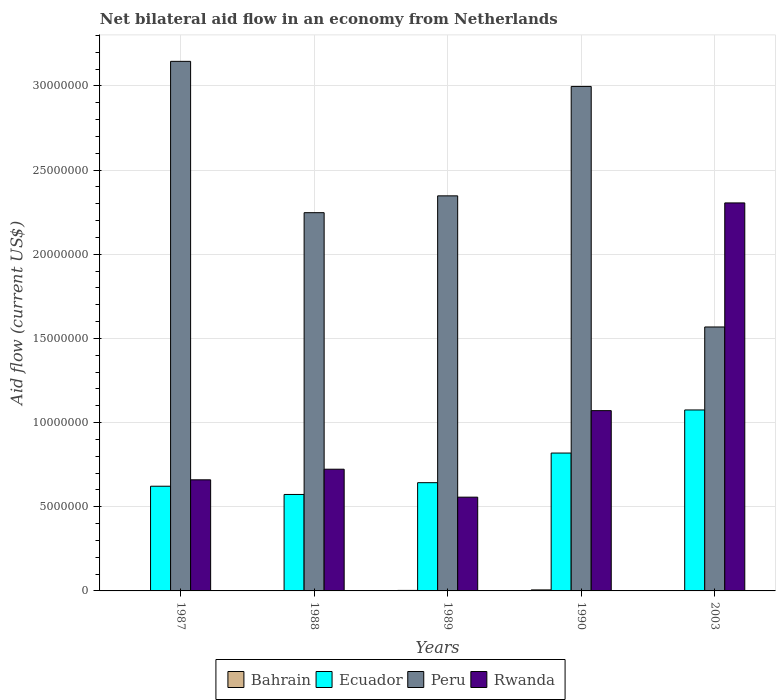How many different coloured bars are there?
Provide a succinct answer. 4. Are the number of bars on each tick of the X-axis equal?
Offer a very short reply. Yes. How many bars are there on the 4th tick from the left?
Your answer should be very brief. 4. What is the label of the 5th group of bars from the left?
Provide a succinct answer. 2003. In how many cases, is the number of bars for a given year not equal to the number of legend labels?
Your answer should be compact. 0. What is the net bilateral aid flow in Rwanda in 1988?
Provide a succinct answer. 7.23e+06. Across all years, what is the maximum net bilateral aid flow in Peru?
Keep it short and to the point. 3.15e+07. Across all years, what is the minimum net bilateral aid flow in Peru?
Your answer should be very brief. 1.57e+07. In which year was the net bilateral aid flow in Ecuador minimum?
Provide a short and direct response. 1988. What is the total net bilateral aid flow in Rwanda in the graph?
Provide a succinct answer. 5.32e+07. What is the difference between the net bilateral aid flow in Bahrain in 1989 and that in 1990?
Make the answer very short. -3.00e+04. What is the difference between the net bilateral aid flow in Peru in 1987 and the net bilateral aid flow in Ecuador in 1989?
Give a very brief answer. 2.50e+07. What is the average net bilateral aid flow in Peru per year?
Provide a succinct answer. 2.46e+07. In the year 1988, what is the difference between the net bilateral aid flow in Ecuador and net bilateral aid flow in Bahrain?
Your answer should be compact. 5.71e+06. What is the ratio of the net bilateral aid flow in Peru in 1988 to that in 1990?
Keep it short and to the point. 0.75. What is the difference between the highest and the second highest net bilateral aid flow in Ecuador?
Your answer should be compact. 2.56e+06. What is the difference between the highest and the lowest net bilateral aid flow in Bahrain?
Provide a succinct answer. 4.00e+04. Is it the case that in every year, the sum of the net bilateral aid flow in Peru and net bilateral aid flow in Ecuador is greater than the sum of net bilateral aid flow in Rwanda and net bilateral aid flow in Bahrain?
Make the answer very short. Yes. What does the 4th bar from the left in 1987 represents?
Your answer should be very brief. Rwanda. What does the 4th bar from the right in 2003 represents?
Provide a short and direct response. Bahrain. Is it the case that in every year, the sum of the net bilateral aid flow in Rwanda and net bilateral aid flow in Peru is greater than the net bilateral aid flow in Ecuador?
Provide a succinct answer. Yes. How many years are there in the graph?
Keep it short and to the point. 5. Are the values on the major ticks of Y-axis written in scientific E-notation?
Offer a terse response. No. Where does the legend appear in the graph?
Your answer should be compact. Bottom center. How many legend labels are there?
Ensure brevity in your answer.  4. What is the title of the graph?
Your answer should be very brief. Net bilateral aid flow in an economy from Netherlands. What is the label or title of the Y-axis?
Your answer should be compact. Aid flow (current US$). What is the Aid flow (current US$) in Bahrain in 1987?
Provide a short and direct response. 2.00e+04. What is the Aid flow (current US$) of Ecuador in 1987?
Ensure brevity in your answer.  6.22e+06. What is the Aid flow (current US$) in Peru in 1987?
Provide a succinct answer. 3.15e+07. What is the Aid flow (current US$) in Rwanda in 1987?
Ensure brevity in your answer.  6.60e+06. What is the Aid flow (current US$) in Bahrain in 1988?
Provide a short and direct response. 2.00e+04. What is the Aid flow (current US$) in Ecuador in 1988?
Offer a very short reply. 5.73e+06. What is the Aid flow (current US$) in Peru in 1988?
Your response must be concise. 2.25e+07. What is the Aid flow (current US$) in Rwanda in 1988?
Keep it short and to the point. 7.23e+06. What is the Aid flow (current US$) of Bahrain in 1989?
Your answer should be compact. 3.00e+04. What is the Aid flow (current US$) in Ecuador in 1989?
Keep it short and to the point. 6.43e+06. What is the Aid flow (current US$) of Peru in 1989?
Give a very brief answer. 2.35e+07. What is the Aid flow (current US$) in Rwanda in 1989?
Provide a succinct answer. 5.57e+06. What is the Aid flow (current US$) of Ecuador in 1990?
Provide a short and direct response. 8.19e+06. What is the Aid flow (current US$) in Peru in 1990?
Your response must be concise. 3.00e+07. What is the Aid flow (current US$) of Rwanda in 1990?
Keep it short and to the point. 1.07e+07. What is the Aid flow (current US$) in Ecuador in 2003?
Offer a very short reply. 1.08e+07. What is the Aid flow (current US$) of Peru in 2003?
Your answer should be compact. 1.57e+07. What is the Aid flow (current US$) in Rwanda in 2003?
Offer a terse response. 2.30e+07. Across all years, what is the maximum Aid flow (current US$) in Bahrain?
Give a very brief answer. 6.00e+04. Across all years, what is the maximum Aid flow (current US$) in Ecuador?
Your answer should be compact. 1.08e+07. Across all years, what is the maximum Aid flow (current US$) in Peru?
Your answer should be compact. 3.15e+07. Across all years, what is the maximum Aid flow (current US$) in Rwanda?
Ensure brevity in your answer.  2.30e+07. Across all years, what is the minimum Aid flow (current US$) in Ecuador?
Your answer should be very brief. 5.73e+06. Across all years, what is the minimum Aid flow (current US$) of Peru?
Your answer should be very brief. 1.57e+07. Across all years, what is the minimum Aid flow (current US$) in Rwanda?
Make the answer very short. 5.57e+06. What is the total Aid flow (current US$) of Ecuador in the graph?
Ensure brevity in your answer.  3.73e+07. What is the total Aid flow (current US$) in Peru in the graph?
Offer a terse response. 1.23e+08. What is the total Aid flow (current US$) of Rwanda in the graph?
Offer a terse response. 5.32e+07. What is the difference between the Aid flow (current US$) of Ecuador in 1987 and that in 1988?
Provide a short and direct response. 4.90e+05. What is the difference between the Aid flow (current US$) in Peru in 1987 and that in 1988?
Ensure brevity in your answer.  8.99e+06. What is the difference between the Aid flow (current US$) of Rwanda in 1987 and that in 1988?
Offer a very short reply. -6.30e+05. What is the difference between the Aid flow (current US$) of Peru in 1987 and that in 1989?
Make the answer very short. 7.99e+06. What is the difference between the Aid flow (current US$) of Rwanda in 1987 and that in 1989?
Make the answer very short. 1.03e+06. What is the difference between the Aid flow (current US$) in Ecuador in 1987 and that in 1990?
Make the answer very short. -1.97e+06. What is the difference between the Aid flow (current US$) of Peru in 1987 and that in 1990?
Give a very brief answer. 1.49e+06. What is the difference between the Aid flow (current US$) of Rwanda in 1987 and that in 1990?
Your response must be concise. -4.11e+06. What is the difference between the Aid flow (current US$) in Ecuador in 1987 and that in 2003?
Give a very brief answer. -4.53e+06. What is the difference between the Aid flow (current US$) of Peru in 1987 and that in 2003?
Provide a short and direct response. 1.58e+07. What is the difference between the Aid flow (current US$) of Rwanda in 1987 and that in 2003?
Make the answer very short. -1.64e+07. What is the difference between the Aid flow (current US$) in Bahrain in 1988 and that in 1989?
Ensure brevity in your answer.  -10000. What is the difference between the Aid flow (current US$) in Ecuador in 1988 and that in 1989?
Your answer should be compact. -7.00e+05. What is the difference between the Aid flow (current US$) of Rwanda in 1988 and that in 1989?
Make the answer very short. 1.66e+06. What is the difference between the Aid flow (current US$) in Ecuador in 1988 and that in 1990?
Offer a terse response. -2.46e+06. What is the difference between the Aid flow (current US$) in Peru in 1988 and that in 1990?
Your response must be concise. -7.50e+06. What is the difference between the Aid flow (current US$) in Rwanda in 1988 and that in 1990?
Your response must be concise. -3.48e+06. What is the difference between the Aid flow (current US$) of Ecuador in 1988 and that in 2003?
Ensure brevity in your answer.  -5.02e+06. What is the difference between the Aid flow (current US$) in Peru in 1988 and that in 2003?
Make the answer very short. 6.79e+06. What is the difference between the Aid flow (current US$) of Rwanda in 1988 and that in 2003?
Make the answer very short. -1.58e+07. What is the difference between the Aid flow (current US$) in Ecuador in 1989 and that in 1990?
Your response must be concise. -1.76e+06. What is the difference between the Aid flow (current US$) in Peru in 1989 and that in 1990?
Ensure brevity in your answer.  -6.50e+06. What is the difference between the Aid flow (current US$) in Rwanda in 1989 and that in 1990?
Your answer should be very brief. -5.14e+06. What is the difference between the Aid flow (current US$) in Ecuador in 1989 and that in 2003?
Provide a short and direct response. -4.32e+06. What is the difference between the Aid flow (current US$) in Peru in 1989 and that in 2003?
Ensure brevity in your answer.  7.79e+06. What is the difference between the Aid flow (current US$) of Rwanda in 1989 and that in 2003?
Give a very brief answer. -1.75e+07. What is the difference between the Aid flow (current US$) of Ecuador in 1990 and that in 2003?
Provide a succinct answer. -2.56e+06. What is the difference between the Aid flow (current US$) of Peru in 1990 and that in 2003?
Make the answer very short. 1.43e+07. What is the difference between the Aid flow (current US$) in Rwanda in 1990 and that in 2003?
Make the answer very short. -1.23e+07. What is the difference between the Aid flow (current US$) in Bahrain in 1987 and the Aid flow (current US$) in Ecuador in 1988?
Offer a terse response. -5.71e+06. What is the difference between the Aid flow (current US$) in Bahrain in 1987 and the Aid flow (current US$) in Peru in 1988?
Make the answer very short. -2.24e+07. What is the difference between the Aid flow (current US$) in Bahrain in 1987 and the Aid flow (current US$) in Rwanda in 1988?
Keep it short and to the point. -7.21e+06. What is the difference between the Aid flow (current US$) in Ecuador in 1987 and the Aid flow (current US$) in Peru in 1988?
Provide a short and direct response. -1.62e+07. What is the difference between the Aid flow (current US$) of Ecuador in 1987 and the Aid flow (current US$) of Rwanda in 1988?
Offer a terse response. -1.01e+06. What is the difference between the Aid flow (current US$) in Peru in 1987 and the Aid flow (current US$) in Rwanda in 1988?
Your response must be concise. 2.42e+07. What is the difference between the Aid flow (current US$) of Bahrain in 1987 and the Aid flow (current US$) of Ecuador in 1989?
Your answer should be very brief. -6.41e+06. What is the difference between the Aid flow (current US$) of Bahrain in 1987 and the Aid flow (current US$) of Peru in 1989?
Provide a succinct answer. -2.34e+07. What is the difference between the Aid flow (current US$) in Bahrain in 1987 and the Aid flow (current US$) in Rwanda in 1989?
Your answer should be very brief. -5.55e+06. What is the difference between the Aid flow (current US$) in Ecuador in 1987 and the Aid flow (current US$) in Peru in 1989?
Keep it short and to the point. -1.72e+07. What is the difference between the Aid flow (current US$) in Ecuador in 1987 and the Aid flow (current US$) in Rwanda in 1989?
Provide a short and direct response. 6.50e+05. What is the difference between the Aid flow (current US$) in Peru in 1987 and the Aid flow (current US$) in Rwanda in 1989?
Provide a short and direct response. 2.59e+07. What is the difference between the Aid flow (current US$) of Bahrain in 1987 and the Aid flow (current US$) of Ecuador in 1990?
Make the answer very short. -8.17e+06. What is the difference between the Aid flow (current US$) of Bahrain in 1987 and the Aid flow (current US$) of Peru in 1990?
Give a very brief answer. -3.00e+07. What is the difference between the Aid flow (current US$) of Bahrain in 1987 and the Aid flow (current US$) of Rwanda in 1990?
Provide a short and direct response. -1.07e+07. What is the difference between the Aid flow (current US$) of Ecuador in 1987 and the Aid flow (current US$) of Peru in 1990?
Your response must be concise. -2.38e+07. What is the difference between the Aid flow (current US$) in Ecuador in 1987 and the Aid flow (current US$) in Rwanda in 1990?
Your answer should be very brief. -4.49e+06. What is the difference between the Aid flow (current US$) in Peru in 1987 and the Aid flow (current US$) in Rwanda in 1990?
Your response must be concise. 2.08e+07. What is the difference between the Aid flow (current US$) of Bahrain in 1987 and the Aid flow (current US$) of Ecuador in 2003?
Keep it short and to the point. -1.07e+07. What is the difference between the Aid flow (current US$) of Bahrain in 1987 and the Aid flow (current US$) of Peru in 2003?
Offer a very short reply. -1.57e+07. What is the difference between the Aid flow (current US$) of Bahrain in 1987 and the Aid flow (current US$) of Rwanda in 2003?
Provide a succinct answer. -2.30e+07. What is the difference between the Aid flow (current US$) of Ecuador in 1987 and the Aid flow (current US$) of Peru in 2003?
Your response must be concise. -9.46e+06. What is the difference between the Aid flow (current US$) in Ecuador in 1987 and the Aid flow (current US$) in Rwanda in 2003?
Keep it short and to the point. -1.68e+07. What is the difference between the Aid flow (current US$) in Peru in 1987 and the Aid flow (current US$) in Rwanda in 2003?
Your answer should be compact. 8.41e+06. What is the difference between the Aid flow (current US$) in Bahrain in 1988 and the Aid flow (current US$) in Ecuador in 1989?
Keep it short and to the point. -6.41e+06. What is the difference between the Aid flow (current US$) of Bahrain in 1988 and the Aid flow (current US$) of Peru in 1989?
Your answer should be very brief. -2.34e+07. What is the difference between the Aid flow (current US$) in Bahrain in 1988 and the Aid flow (current US$) in Rwanda in 1989?
Provide a succinct answer. -5.55e+06. What is the difference between the Aid flow (current US$) in Ecuador in 1988 and the Aid flow (current US$) in Peru in 1989?
Your answer should be compact. -1.77e+07. What is the difference between the Aid flow (current US$) of Ecuador in 1988 and the Aid flow (current US$) of Rwanda in 1989?
Ensure brevity in your answer.  1.60e+05. What is the difference between the Aid flow (current US$) in Peru in 1988 and the Aid flow (current US$) in Rwanda in 1989?
Offer a terse response. 1.69e+07. What is the difference between the Aid flow (current US$) of Bahrain in 1988 and the Aid flow (current US$) of Ecuador in 1990?
Your answer should be very brief. -8.17e+06. What is the difference between the Aid flow (current US$) in Bahrain in 1988 and the Aid flow (current US$) in Peru in 1990?
Provide a short and direct response. -3.00e+07. What is the difference between the Aid flow (current US$) in Bahrain in 1988 and the Aid flow (current US$) in Rwanda in 1990?
Your answer should be very brief. -1.07e+07. What is the difference between the Aid flow (current US$) in Ecuador in 1988 and the Aid flow (current US$) in Peru in 1990?
Your response must be concise. -2.42e+07. What is the difference between the Aid flow (current US$) of Ecuador in 1988 and the Aid flow (current US$) of Rwanda in 1990?
Keep it short and to the point. -4.98e+06. What is the difference between the Aid flow (current US$) in Peru in 1988 and the Aid flow (current US$) in Rwanda in 1990?
Your answer should be very brief. 1.18e+07. What is the difference between the Aid flow (current US$) in Bahrain in 1988 and the Aid flow (current US$) in Ecuador in 2003?
Provide a succinct answer. -1.07e+07. What is the difference between the Aid flow (current US$) of Bahrain in 1988 and the Aid flow (current US$) of Peru in 2003?
Provide a short and direct response. -1.57e+07. What is the difference between the Aid flow (current US$) of Bahrain in 1988 and the Aid flow (current US$) of Rwanda in 2003?
Offer a very short reply. -2.30e+07. What is the difference between the Aid flow (current US$) of Ecuador in 1988 and the Aid flow (current US$) of Peru in 2003?
Your answer should be very brief. -9.95e+06. What is the difference between the Aid flow (current US$) of Ecuador in 1988 and the Aid flow (current US$) of Rwanda in 2003?
Provide a succinct answer. -1.73e+07. What is the difference between the Aid flow (current US$) in Peru in 1988 and the Aid flow (current US$) in Rwanda in 2003?
Your response must be concise. -5.80e+05. What is the difference between the Aid flow (current US$) of Bahrain in 1989 and the Aid flow (current US$) of Ecuador in 1990?
Your answer should be very brief. -8.16e+06. What is the difference between the Aid flow (current US$) of Bahrain in 1989 and the Aid flow (current US$) of Peru in 1990?
Provide a succinct answer. -2.99e+07. What is the difference between the Aid flow (current US$) of Bahrain in 1989 and the Aid flow (current US$) of Rwanda in 1990?
Offer a terse response. -1.07e+07. What is the difference between the Aid flow (current US$) of Ecuador in 1989 and the Aid flow (current US$) of Peru in 1990?
Provide a short and direct response. -2.35e+07. What is the difference between the Aid flow (current US$) of Ecuador in 1989 and the Aid flow (current US$) of Rwanda in 1990?
Make the answer very short. -4.28e+06. What is the difference between the Aid flow (current US$) in Peru in 1989 and the Aid flow (current US$) in Rwanda in 1990?
Ensure brevity in your answer.  1.28e+07. What is the difference between the Aid flow (current US$) of Bahrain in 1989 and the Aid flow (current US$) of Ecuador in 2003?
Your answer should be compact. -1.07e+07. What is the difference between the Aid flow (current US$) of Bahrain in 1989 and the Aid flow (current US$) of Peru in 2003?
Keep it short and to the point. -1.56e+07. What is the difference between the Aid flow (current US$) of Bahrain in 1989 and the Aid flow (current US$) of Rwanda in 2003?
Offer a very short reply. -2.30e+07. What is the difference between the Aid flow (current US$) in Ecuador in 1989 and the Aid flow (current US$) in Peru in 2003?
Offer a terse response. -9.25e+06. What is the difference between the Aid flow (current US$) in Ecuador in 1989 and the Aid flow (current US$) in Rwanda in 2003?
Keep it short and to the point. -1.66e+07. What is the difference between the Aid flow (current US$) in Peru in 1989 and the Aid flow (current US$) in Rwanda in 2003?
Provide a succinct answer. 4.20e+05. What is the difference between the Aid flow (current US$) in Bahrain in 1990 and the Aid flow (current US$) in Ecuador in 2003?
Provide a succinct answer. -1.07e+07. What is the difference between the Aid flow (current US$) in Bahrain in 1990 and the Aid flow (current US$) in Peru in 2003?
Your answer should be very brief. -1.56e+07. What is the difference between the Aid flow (current US$) in Bahrain in 1990 and the Aid flow (current US$) in Rwanda in 2003?
Keep it short and to the point. -2.30e+07. What is the difference between the Aid flow (current US$) of Ecuador in 1990 and the Aid flow (current US$) of Peru in 2003?
Your answer should be very brief. -7.49e+06. What is the difference between the Aid flow (current US$) of Ecuador in 1990 and the Aid flow (current US$) of Rwanda in 2003?
Provide a succinct answer. -1.49e+07. What is the difference between the Aid flow (current US$) of Peru in 1990 and the Aid flow (current US$) of Rwanda in 2003?
Keep it short and to the point. 6.92e+06. What is the average Aid flow (current US$) in Bahrain per year?
Provide a succinct answer. 3.00e+04. What is the average Aid flow (current US$) in Ecuador per year?
Make the answer very short. 7.46e+06. What is the average Aid flow (current US$) in Peru per year?
Make the answer very short. 2.46e+07. What is the average Aid flow (current US$) in Rwanda per year?
Make the answer very short. 1.06e+07. In the year 1987, what is the difference between the Aid flow (current US$) in Bahrain and Aid flow (current US$) in Ecuador?
Make the answer very short. -6.20e+06. In the year 1987, what is the difference between the Aid flow (current US$) of Bahrain and Aid flow (current US$) of Peru?
Ensure brevity in your answer.  -3.14e+07. In the year 1987, what is the difference between the Aid flow (current US$) of Bahrain and Aid flow (current US$) of Rwanda?
Offer a very short reply. -6.58e+06. In the year 1987, what is the difference between the Aid flow (current US$) of Ecuador and Aid flow (current US$) of Peru?
Your answer should be compact. -2.52e+07. In the year 1987, what is the difference between the Aid flow (current US$) in Ecuador and Aid flow (current US$) in Rwanda?
Your response must be concise. -3.80e+05. In the year 1987, what is the difference between the Aid flow (current US$) in Peru and Aid flow (current US$) in Rwanda?
Make the answer very short. 2.49e+07. In the year 1988, what is the difference between the Aid flow (current US$) in Bahrain and Aid flow (current US$) in Ecuador?
Your response must be concise. -5.71e+06. In the year 1988, what is the difference between the Aid flow (current US$) of Bahrain and Aid flow (current US$) of Peru?
Provide a short and direct response. -2.24e+07. In the year 1988, what is the difference between the Aid flow (current US$) of Bahrain and Aid flow (current US$) of Rwanda?
Your answer should be very brief. -7.21e+06. In the year 1988, what is the difference between the Aid flow (current US$) in Ecuador and Aid flow (current US$) in Peru?
Make the answer very short. -1.67e+07. In the year 1988, what is the difference between the Aid flow (current US$) in Ecuador and Aid flow (current US$) in Rwanda?
Your answer should be very brief. -1.50e+06. In the year 1988, what is the difference between the Aid flow (current US$) of Peru and Aid flow (current US$) of Rwanda?
Provide a short and direct response. 1.52e+07. In the year 1989, what is the difference between the Aid flow (current US$) of Bahrain and Aid flow (current US$) of Ecuador?
Your answer should be very brief. -6.40e+06. In the year 1989, what is the difference between the Aid flow (current US$) in Bahrain and Aid flow (current US$) in Peru?
Give a very brief answer. -2.34e+07. In the year 1989, what is the difference between the Aid flow (current US$) of Bahrain and Aid flow (current US$) of Rwanda?
Offer a terse response. -5.54e+06. In the year 1989, what is the difference between the Aid flow (current US$) of Ecuador and Aid flow (current US$) of Peru?
Make the answer very short. -1.70e+07. In the year 1989, what is the difference between the Aid flow (current US$) of Ecuador and Aid flow (current US$) of Rwanda?
Keep it short and to the point. 8.60e+05. In the year 1989, what is the difference between the Aid flow (current US$) of Peru and Aid flow (current US$) of Rwanda?
Your answer should be very brief. 1.79e+07. In the year 1990, what is the difference between the Aid flow (current US$) in Bahrain and Aid flow (current US$) in Ecuador?
Make the answer very short. -8.13e+06. In the year 1990, what is the difference between the Aid flow (current US$) of Bahrain and Aid flow (current US$) of Peru?
Offer a terse response. -2.99e+07. In the year 1990, what is the difference between the Aid flow (current US$) of Bahrain and Aid flow (current US$) of Rwanda?
Ensure brevity in your answer.  -1.06e+07. In the year 1990, what is the difference between the Aid flow (current US$) in Ecuador and Aid flow (current US$) in Peru?
Keep it short and to the point. -2.18e+07. In the year 1990, what is the difference between the Aid flow (current US$) in Ecuador and Aid flow (current US$) in Rwanda?
Ensure brevity in your answer.  -2.52e+06. In the year 1990, what is the difference between the Aid flow (current US$) in Peru and Aid flow (current US$) in Rwanda?
Keep it short and to the point. 1.93e+07. In the year 2003, what is the difference between the Aid flow (current US$) in Bahrain and Aid flow (current US$) in Ecuador?
Offer a very short reply. -1.07e+07. In the year 2003, what is the difference between the Aid flow (current US$) in Bahrain and Aid flow (current US$) in Peru?
Keep it short and to the point. -1.57e+07. In the year 2003, what is the difference between the Aid flow (current US$) in Bahrain and Aid flow (current US$) in Rwanda?
Make the answer very short. -2.30e+07. In the year 2003, what is the difference between the Aid flow (current US$) in Ecuador and Aid flow (current US$) in Peru?
Offer a terse response. -4.93e+06. In the year 2003, what is the difference between the Aid flow (current US$) of Ecuador and Aid flow (current US$) of Rwanda?
Offer a terse response. -1.23e+07. In the year 2003, what is the difference between the Aid flow (current US$) of Peru and Aid flow (current US$) of Rwanda?
Keep it short and to the point. -7.37e+06. What is the ratio of the Aid flow (current US$) in Bahrain in 1987 to that in 1988?
Provide a short and direct response. 1. What is the ratio of the Aid flow (current US$) of Ecuador in 1987 to that in 1988?
Give a very brief answer. 1.09. What is the ratio of the Aid flow (current US$) in Peru in 1987 to that in 1988?
Offer a terse response. 1.4. What is the ratio of the Aid flow (current US$) in Rwanda in 1987 to that in 1988?
Provide a succinct answer. 0.91. What is the ratio of the Aid flow (current US$) in Bahrain in 1987 to that in 1989?
Make the answer very short. 0.67. What is the ratio of the Aid flow (current US$) of Ecuador in 1987 to that in 1989?
Make the answer very short. 0.97. What is the ratio of the Aid flow (current US$) of Peru in 1987 to that in 1989?
Your answer should be very brief. 1.34. What is the ratio of the Aid flow (current US$) of Rwanda in 1987 to that in 1989?
Give a very brief answer. 1.18. What is the ratio of the Aid flow (current US$) in Bahrain in 1987 to that in 1990?
Give a very brief answer. 0.33. What is the ratio of the Aid flow (current US$) in Ecuador in 1987 to that in 1990?
Make the answer very short. 0.76. What is the ratio of the Aid flow (current US$) of Peru in 1987 to that in 1990?
Provide a succinct answer. 1.05. What is the ratio of the Aid flow (current US$) in Rwanda in 1987 to that in 1990?
Your answer should be compact. 0.62. What is the ratio of the Aid flow (current US$) in Bahrain in 1987 to that in 2003?
Make the answer very short. 1. What is the ratio of the Aid flow (current US$) of Ecuador in 1987 to that in 2003?
Keep it short and to the point. 0.58. What is the ratio of the Aid flow (current US$) of Peru in 1987 to that in 2003?
Provide a succinct answer. 2.01. What is the ratio of the Aid flow (current US$) in Rwanda in 1987 to that in 2003?
Your response must be concise. 0.29. What is the ratio of the Aid flow (current US$) of Ecuador in 1988 to that in 1989?
Provide a succinct answer. 0.89. What is the ratio of the Aid flow (current US$) of Peru in 1988 to that in 1989?
Offer a very short reply. 0.96. What is the ratio of the Aid flow (current US$) in Rwanda in 1988 to that in 1989?
Provide a succinct answer. 1.3. What is the ratio of the Aid flow (current US$) of Ecuador in 1988 to that in 1990?
Offer a very short reply. 0.7. What is the ratio of the Aid flow (current US$) in Peru in 1988 to that in 1990?
Provide a succinct answer. 0.75. What is the ratio of the Aid flow (current US$) in Rwanda in 1988 to that in 1990?
Offer a very short reply. 0.68. What is the ratio of the Aid flow (current US$) of Ecuador in 1988 to that in 2003?
Your answer should be very brief. 0.53. What is the ratio of the Aid flow (current US$) of Peru in 1988 to that in 2003?
Your response must be concise. 1.43. What is the ratio of the Aid flow (current US$) of Rwanda in 1988 to that in 2003?
Ensure brevity in your answer.  0.31. What is the ratio of the Aid flow (current US$) in Ecuador in 1989 to that in 1990?
Give a very brief answer. 0.79. What is the ratio of the Aid flow (current US$) of Peru in 1989 to that in 1990?
Provide a succinct answer. 0.78. What is the ratio of the Aid flow (current US$) of Rwanda in 1989 to that in 1990?
Offer a very short reply. 0.52. What is the ratio of the Aid flow (current US$) in Bahrain in 1989 to that in 2003?
Your answer should be very brief. 1.5. What is the ratio of the Aid flow (current US$) in Ecuador in 1989 to that in 2003?
Your answer should be very brief. 0.6. What is the ratio of the Aid flow (current US$) in Peru in 1989 to that in 2003?
Your response must be concise. 1.5. What is the ratio of the Aid flow (current US$) in Rwanda in 1989 to that in 2003?
Your answer should be compact. 0.24. What is the ratio of the Aid flow (current US$) in Ecuador in 1990 to that in 2003?
Make the answer very short. 0.76. What is the ratio of the Aid flow (current US$) of Peru in 1990 to that in 2003?
Ensure brevity in your answer.  1.91. What is the ratio of the Aid flow (current US$) in Rwanda in 1990 to that in 2003?
Make the answer very short. 0.46. What is the difference between the highest and the second highest Aid flow (current US$) of Ecuador?
Ensure brevity in your answer.  2.56e+06. What is the difference between the highest and the second highest Aid flow (current US$) of Peru?
Provide a succinct answer. 1.49e+06. What is the difference between the highest and the second highest Aid flow (current US$) in Rwanda?
Ensure brevity in your answer.  1.23e+07. What is the difference between the highest and the lowest Aid flow (current US$) of Ecuador?
Offer a very short reply. 5.02e+06. What is the difference between the highest and the lowest Aid flow (current US$) of Peru?
Your response must be concise. 1.58e+07. What is the difference between the highest and the lowest Aid flow (current US$) in Rwanda?
Ensure brevity in your answer.  1.75e+07. 